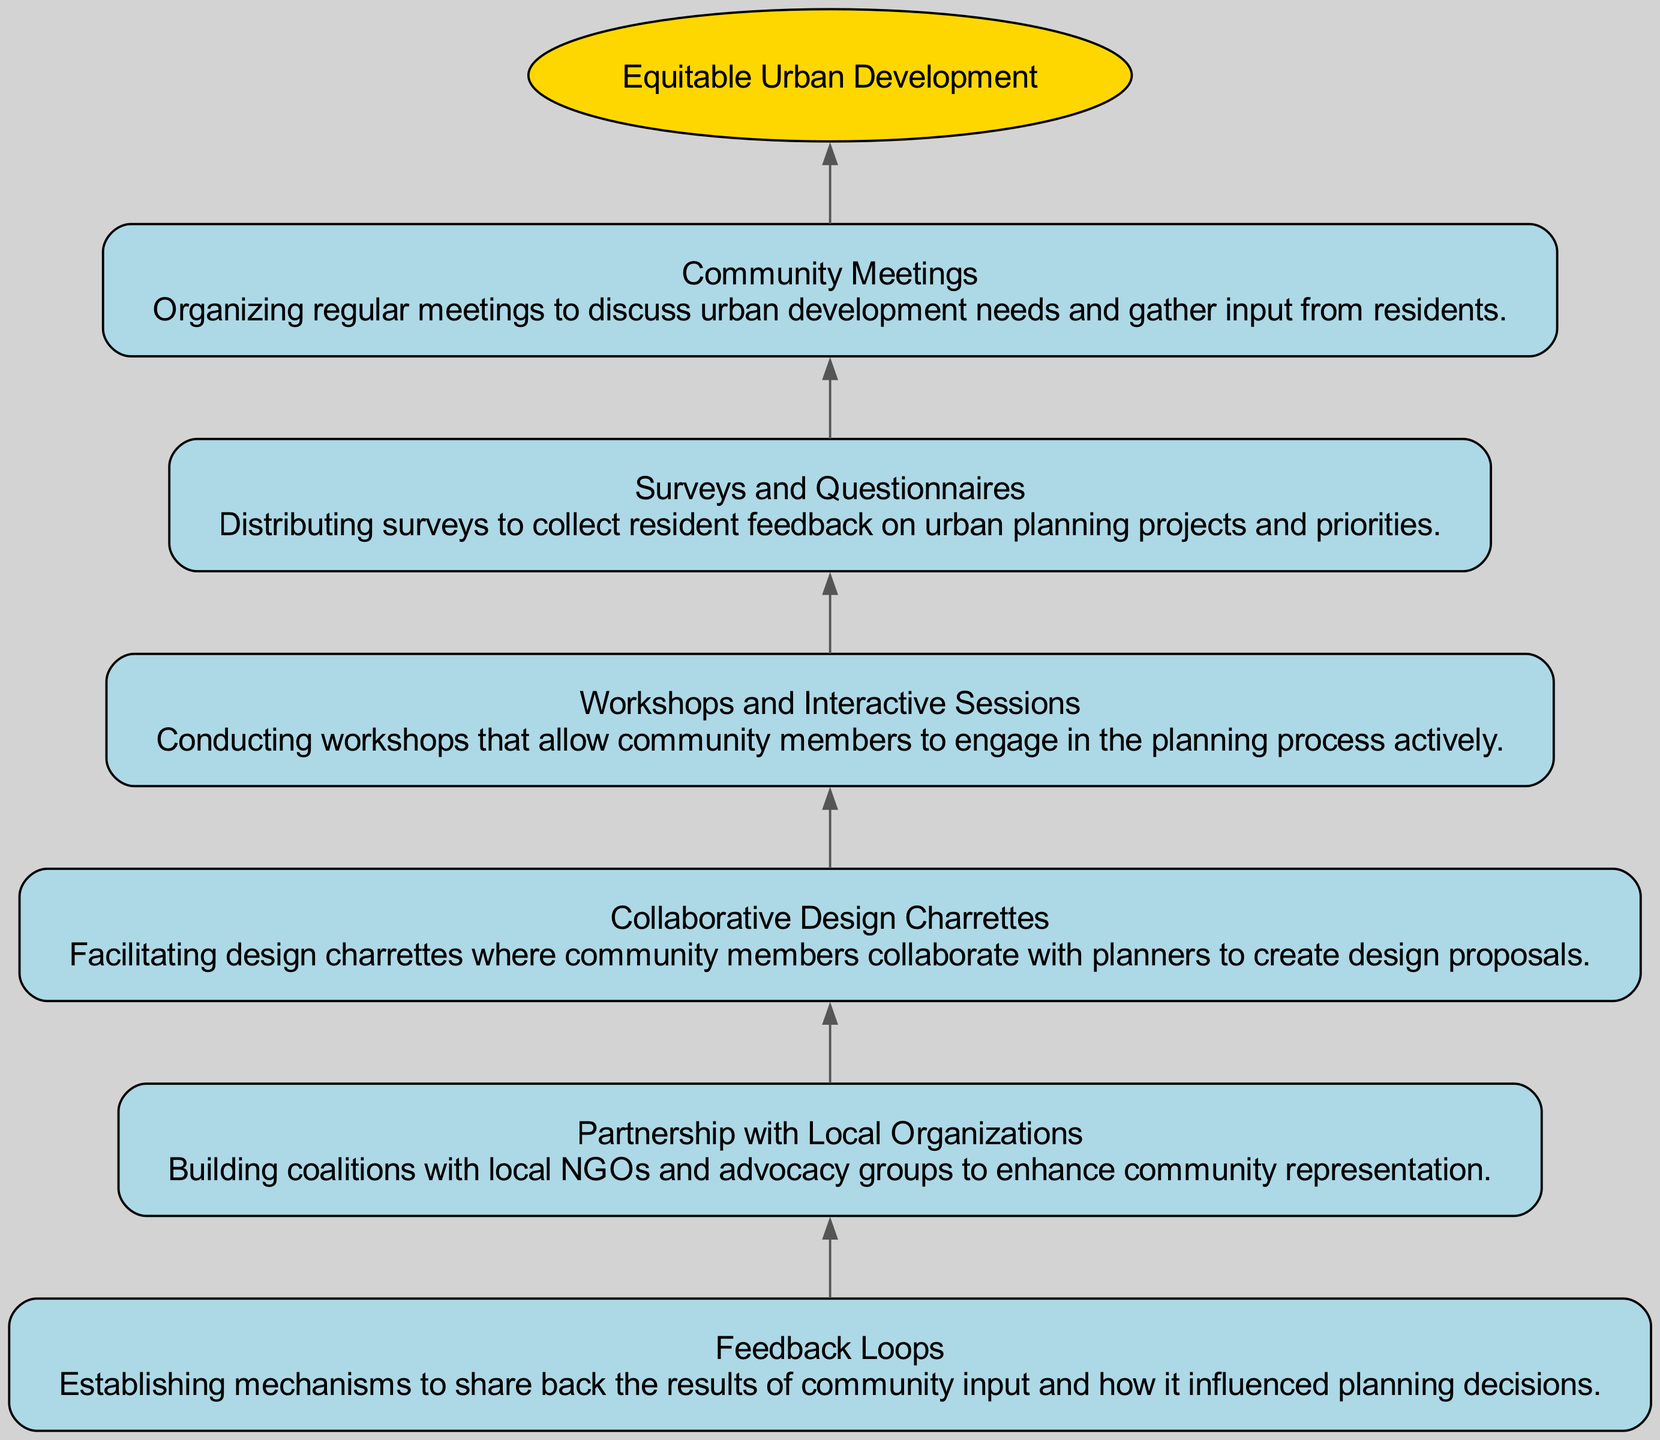What are the key community engagement initiatives listed? The diagram outlines six key initiatives: Community Meetings, Surveys and Questionnaires, Workshops and Interactive Sessions, Collaborative Design Charrettes, Partnership with Local Organizations, and Feedback Loops. These initiatives are presented as nodes in the visual representation.
Answer: Community Meetings, Surveys and Questionnaires, Workshops and Interactive Sessions, Collaborative Design Charrettes, Partnership with Local Organizations, Feedback Loops How many total nodes are in the diagram? The diagram includes a total of seven nodes: one root node (Equitable Urban Development) and six community engagement initiative nodes. Counting all the nodes gives us seven in total.
Answer: 7 Which initiative follows directly after Workshops and Interactive Sessions? In the flow from the bottom-up, after Workshops and Interactive Sessions is the Collaborative Design Charrettes. This is determined by tracing the edges in the diagram that link the nodes sequentially.
Answer: Collaborative Design Charrettes What is the purpose of Feedback Loops in the context of this diagram? The Feedback Loops node is designed to establish mechanisms for sharing how community input has influenced planning decisions. It is indicated as a crucial step in the process of engaging the community in urban development.
Answer: Share results of community input Which community engagement initiative has the first node in the flow? The first node in the flow, according to the bottom-up structure, is Community Meetings. This is denoted as the starting point from which all other initiatives are connected.
Answer: Community Meetings What type of relationship exists between Surveys and Questionnaires and the subsequent initiative in the diagram? The relationship is sequential; Surveys and Questionnaires lead directly to Workshops and Interactive Sessions, indicating that feedback from the surveys may inform the content and structure of the workshops. This is observed through the directed edge that connects the two nodes.
Answer: Sequential relationship How many edges connect the nodes in this diagram? The diagram shows a total of six edges, connecting each node to the one directly above it, culminating at the root node. Each initiative directs to its predecessor, resulting in a linear connection.
Answer: 6 What role does Partnership with Local Organizations play in community engagement? The Partnership with Local Organizations is crucial for building coalitions with NGOs and advocacy groups, enhancing community representation in planning processes. It highlights the importance of collaboration in effective urban development initiatives.
Answer: Enhance community representation 